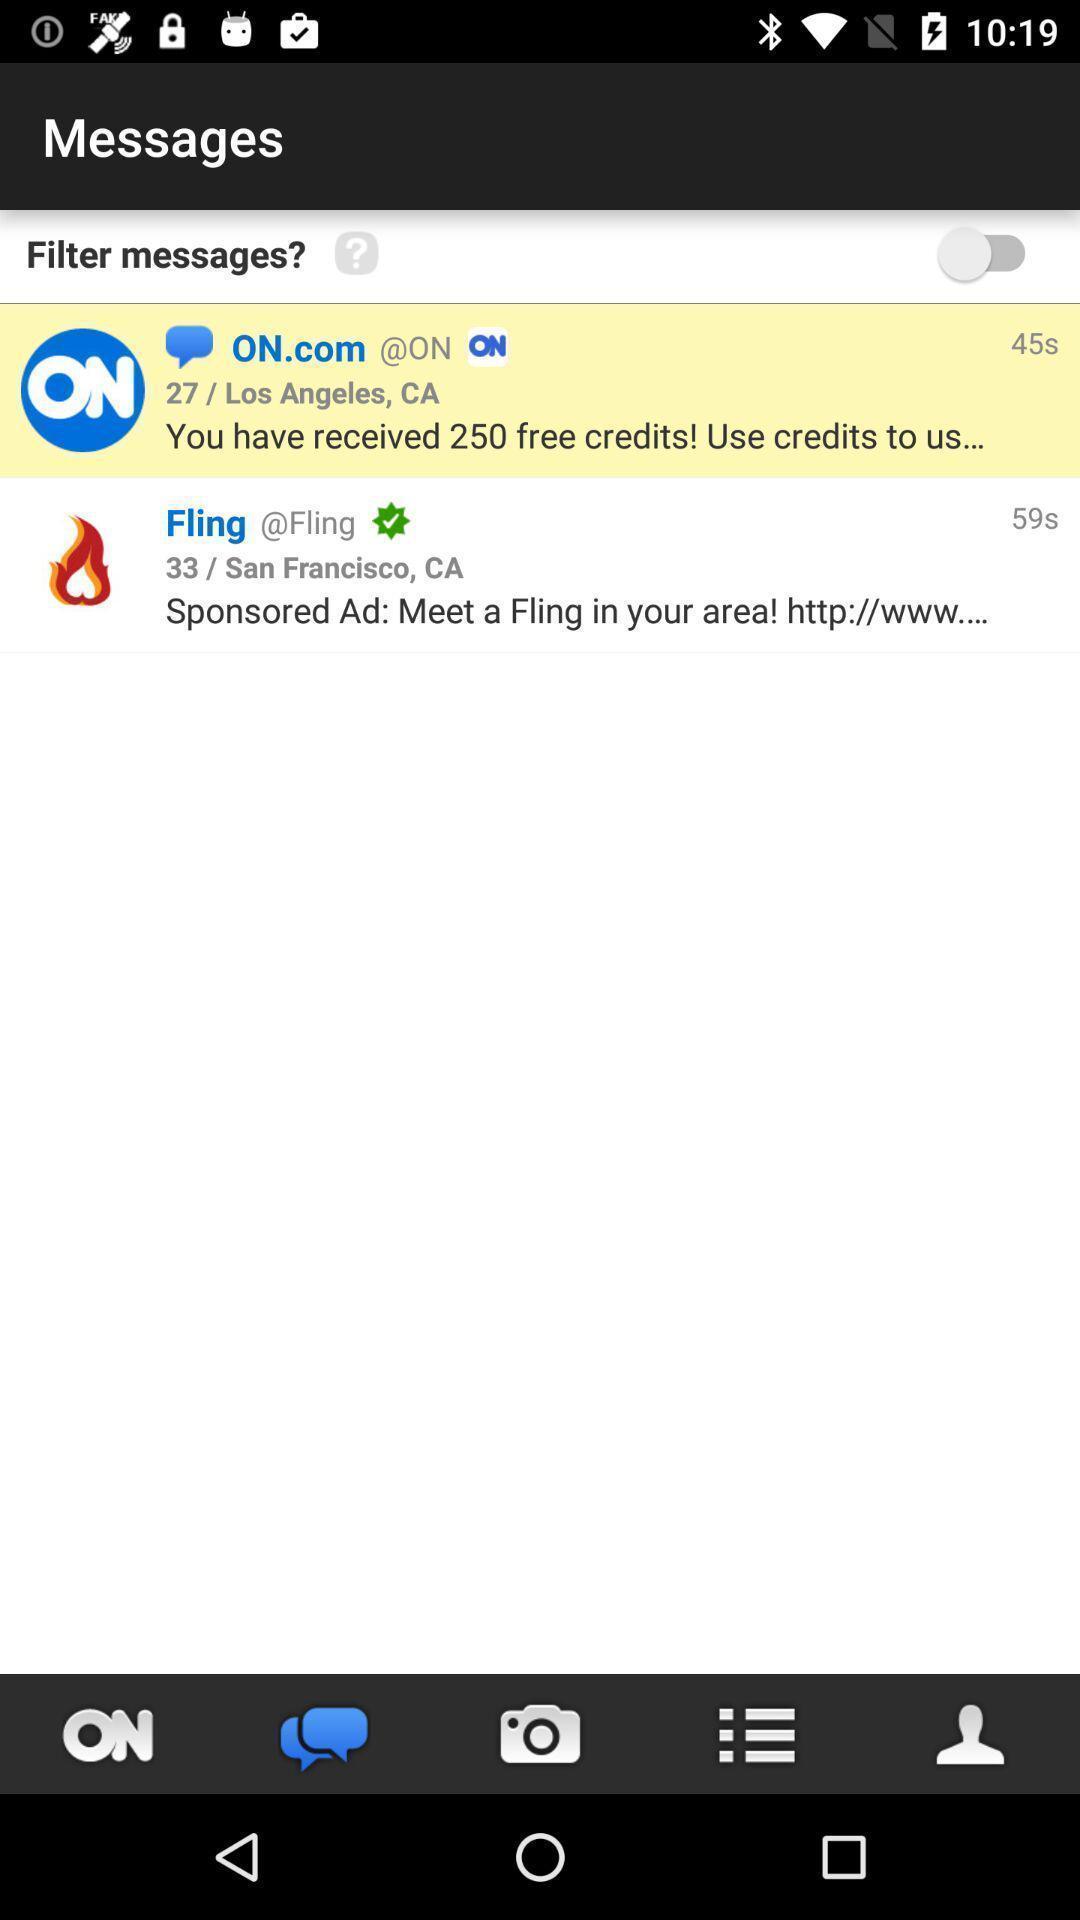Summarize the main components in this picture. Screen displaying the messages page. 